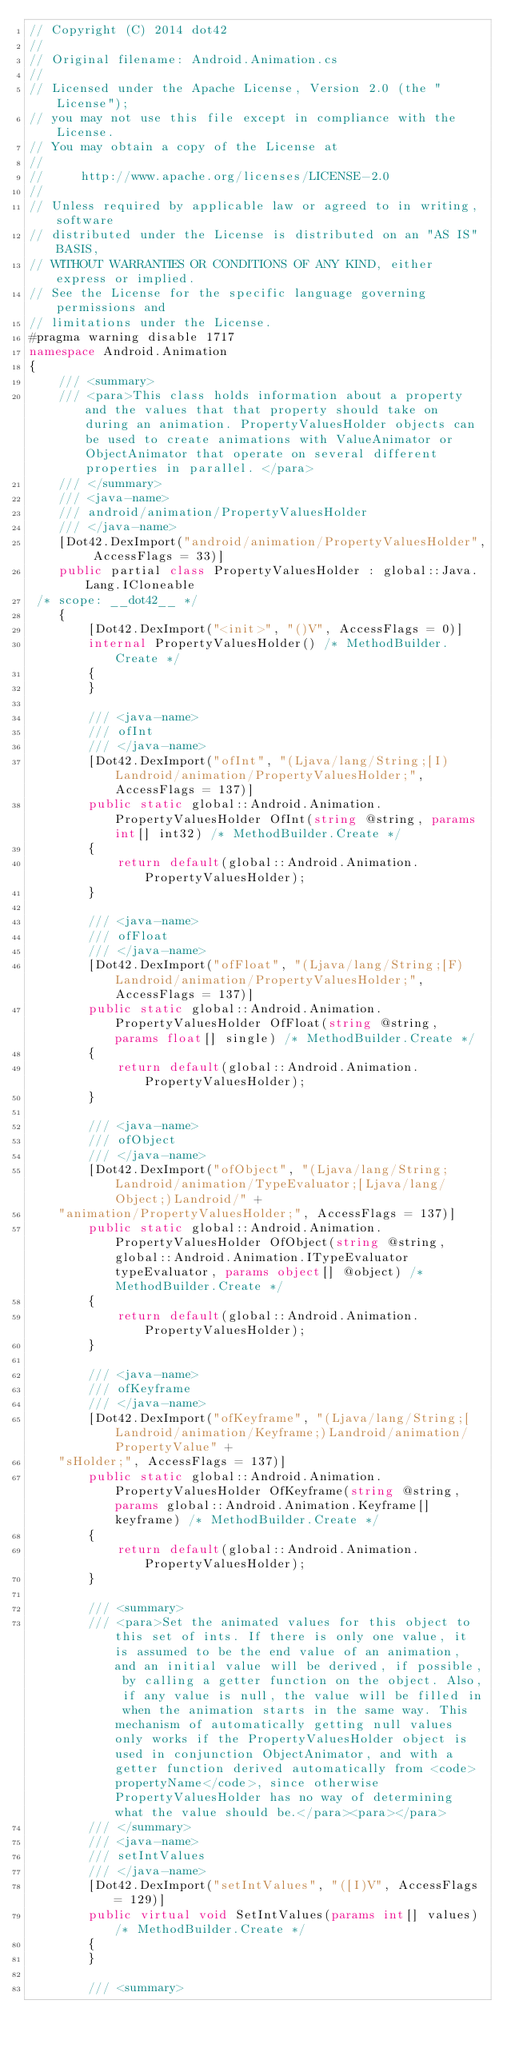Convert code to text. <code><loc_0><loc_0><loc_500><loc_500><_C#_>// Copyright (C) 2014 dot42
//
// Original filename: Android.Animation.cs
//
// Licensed under the Apache License, Version 2.0 (the "License");
// you may not use this file except in compliance with the License.
// You may obtain a copy of the License at
// 
//     http://www.apache.org/licenses/LICENSE-2.0
// 
// Unless required by applicable law or agreed to in writing, software
// distributed under the License is distributed on an "AS IS" BASIS,
// WITHOUT WARRANTIES OR CONDITIONS OF ANY KIND, either express or implied.
// See the License for the specific language governing permissions and
// limitations under the License.
#pragma warning disable 1717
namespace Android.Animation
{
		/// <summary>
		/// <para>This class holds information about a property and the values that that property should take on during an animation. PropertyValuesHolder objects can be used to create animations with ValueAnimator or ObjectAnimator that operate on several different properties in parallel. </para>    
		/// </summary>
		/// <java-name>
		/// android/animation/PropertyValuesHolder
		/// </java-name>
		[Dot42.DexImport("android/animation/PropertyValuesHolder", AccessFlags = 33)]
		public partial class PropertyValuesHolder : global::Java.Lang.ICloneable
 /* scope: __dot42__ */ 
		{
				[Dot42.DexImport("<init>", "()V", AccessFlags = 0)]
				internal PropertyValuesHolder() /* MethodBuilder.Create */ 
				{
				}

				/// <java-name>
				/// ofInt
				/// </java-name>
				[Dot42.DexImport("ofInt", "(Ljava/lang/String;[I)Landroid/animation/PropertyValuesHolder;", AccessFlags = 137)]
				public static global::Android.Animation.PropertyValuesHolder OfInt(string @string, params int[] int32) /* MethodBuilder.Create */ 
				{
						return default(global::Android.Animation.PropertyValuesHolder);
				}

				/// <java-name>
				/// ofFloat
				/// </java-name>
				[Dot42.DexImport("ofFloat", "(Ljava/lang/String;[F)Landroid/animation/PropertyValuesHolder;", AccessFlags = 137)]
				public static global::Android.Animation.PropertyValuesHolder OfFloat(string @string, params float[] single) /* MethodBuilder.Create */ 
				{
						return default(global::Android.Animation.PropertyValuesHolder);
				}

				/// <java-name>
				/// ofObject
				/// </java-name>
				[Dot42.DexImport("ofObject", "(Ljava/lang/String;Landroid/animation/TypeEvaluator;[Ljava/lang/Object;)Landroid/" +
    "animation/PropertyValuesHolder;", AccessFlags = 137)]
				public static global::Android.Animation.PropertyValuesHolder OfObject(string @string, global::Android.Animation.ITypeEvaluator typeEvaluator, params object[] @object) /* MethodBuilder.Create */ 
				{
						return default(global::Android.Animation.PropertyValuesHolder);
				}

				/// <java-name>
				/// ofKeyframe
				/// </java-name>
				[Dot42.DexImport("ofKeyframe", "(Ljava/lang/String;[Landroid/animation/Keyframe;)Landroid/animation/PropertyValue" +
    "sHolder;", AccessFlags = 137)]
				public static global::Android.Animation.PropertyValuesHolder OfKeyframe(string @string, params global::Android.Animation.Keyframe[] keyframe) /* MethodBuilder.Create */ 
				{
						return default(global::Android.Animation.PropertyValuesHolder);
				}

				/// <summary>
				/// <para>Set the animated values for this object to this set of ints. If there is only one value, it is assumed to be the end value of an animation, and an initial value will be derived, if possible, by calling a getter function on the object. Also, if any value is null, the value will be filled in when the animation starts in the same way. This mechanism of automatically getting null values only works if the PropertyValuesHolder object is used in conjunction ObjectAnimator, and with a getter function derived automatically from <code>propertyName</code>, since otherwise PropertyValuesHolder has no way of determining what the value should be.</para><para></para>        
				/// </summary>
				/// <java-name>
				/// setIntValues
				/// </java-name>
				[Dot42.DexImport("setIntValues", "([I)V", AccessFlags = 129)]
				public virtual void SetIntValues(params int[] values) /* MethodBuilder.Create */ 
				{
				}

				/// <summary></code> 